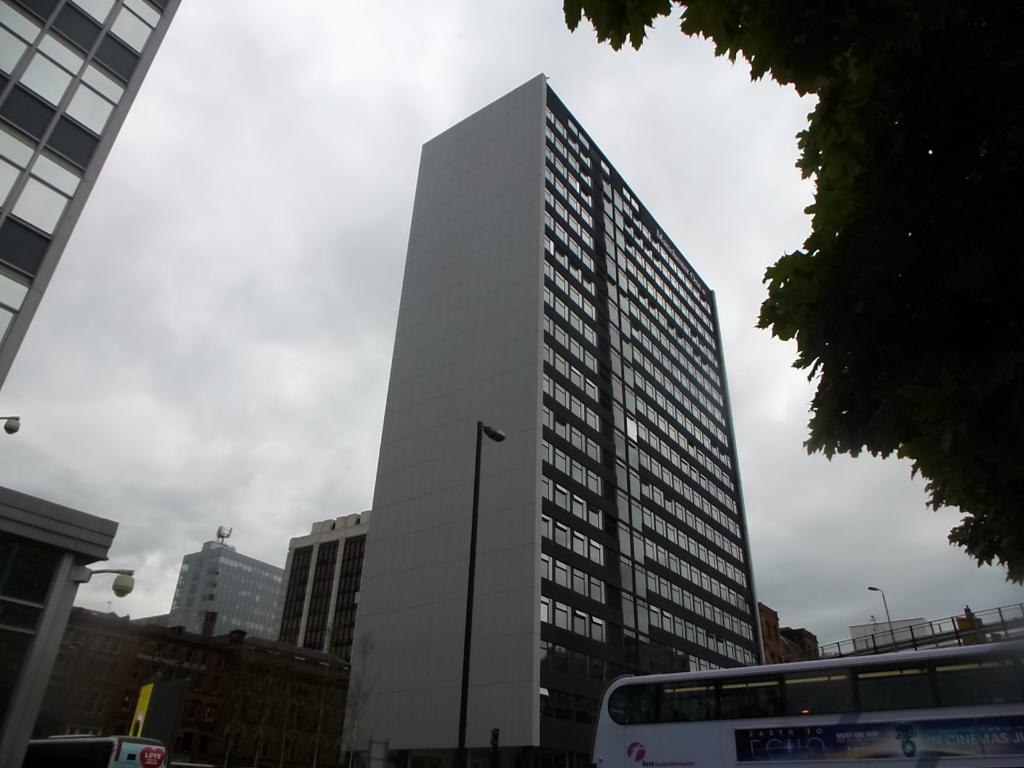How many buses can be seen in the image? There are two buses in the image. What other structures are present in the image besides buses? There are buildings, electric poles with street lights, and a board visible in the image. Are there any natural elements in the image? Yes, trees are visible in the image. What can be seen in the background of the image? The sky with clouds is visible in the background of the image. Can you tell me how low the duck is flying in the image? There is no duck present in the image, so it is not possible to determine its altitude. 